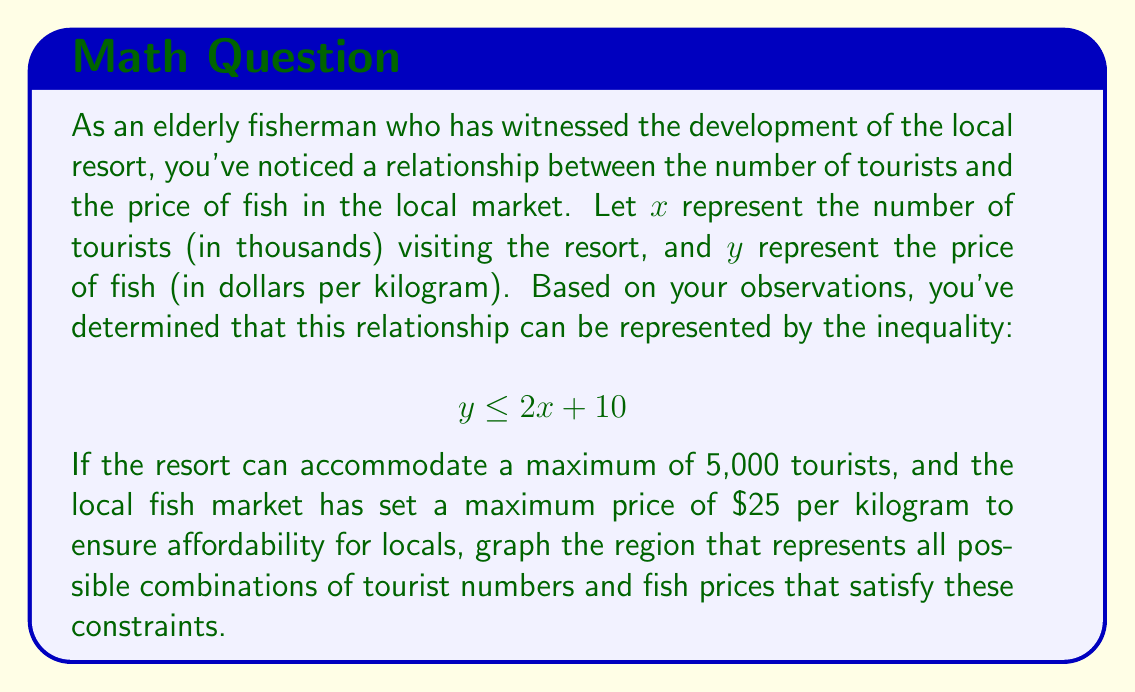Help me with this question. To solve this problem, we need to graph the given inequality along with the additional constraints. Let's break it down step by step:

1. The main inequality: $y \leq 2x + 10$
   This is a linear inequality with a slope of 2 and y-intercept of 10.

2. Maximum number of tourists: $x \leq 5$
   Since $x$ represents thousands of tourists, 5,000 tourists would be represented as $x = 5$.

3. Maximum fish price: $y \leq 25$

Now, let's graph these inequalities:

1. Graph $y = 2x + 10$ as a solid line (since $\leq$ includes the boundary).
2. Shade the area below this line to represent $y \leq 2x + 10$.
3. Draw a vertical line at $x = 5$ and shade to the left to represent $x \leq 5$.
4. Draw a horizontal line at $y = 25$ and shade below to represent $y \leq 25$.

The intersection of all these shaded regions will give us the solution.

[asy]
import graph;
size(200);

xaxis("x (Tourists in thousands)", 0, 6, arrow=Arrow);
yaxis("y (Fish price in $/kg)", 0, 30, arrow=Arrow);

draw((0,10)--(7.5,25), blue);
fill((0,0)--(0,10)--(7.5,25)--(7.5,0)--cycle, lightblue+opacity(0.2));

draw((5,0)--(5,30), red);
fill((0,0)--(5,0)--(5,30)--(0,30)--cycle, red+opacity(0.1));

draw((0,25)--(6,25), green);
fill((0,0)--(6,0)--(6,25)--(0,25)--cycle, green+opacity(0.1));

label("y = 2x + 10", (6,22), E, blue);
label("x = 5", (5,28), N, red);
label("y = 25", (5.5,25), SE, green);

dot((5,25), purple);
label("(5, 25)", (5,25), NE, purple);
[/asy]

The shaded region represents all possible combinations of tourist numbers and fish prices that satisfy the given constraints.

The point of intersection of all three constraints is (5, 25), which represents the maximum number of tourists (5,000) and the maximum fish price ($25/kg).
Answer: The solution is the triangular region bounded by the lines $y = 2x + 10$, $x = 5$, and $y = 25$, with vertices at approximately (0, 10), (5, 25), and (5, 20). 